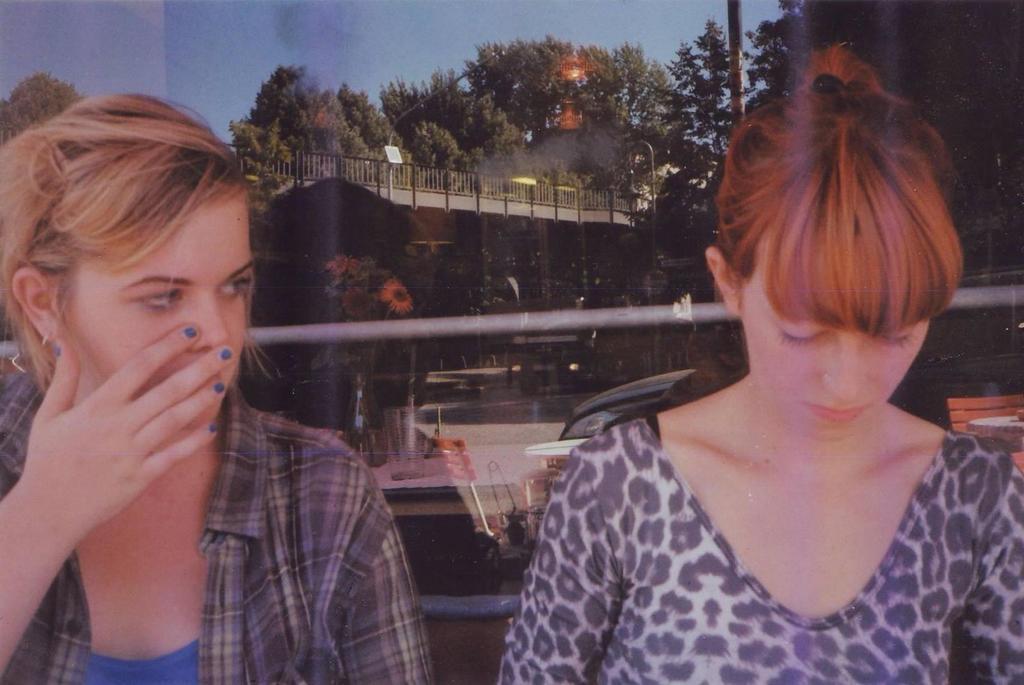Describe this image in one or two sentences. In this picture there are two women who are standing near to the glass partition. In the glass reflection I can see the sky, trees, bridge, railing, poles, plants, grass, flowers, table and chairs. 